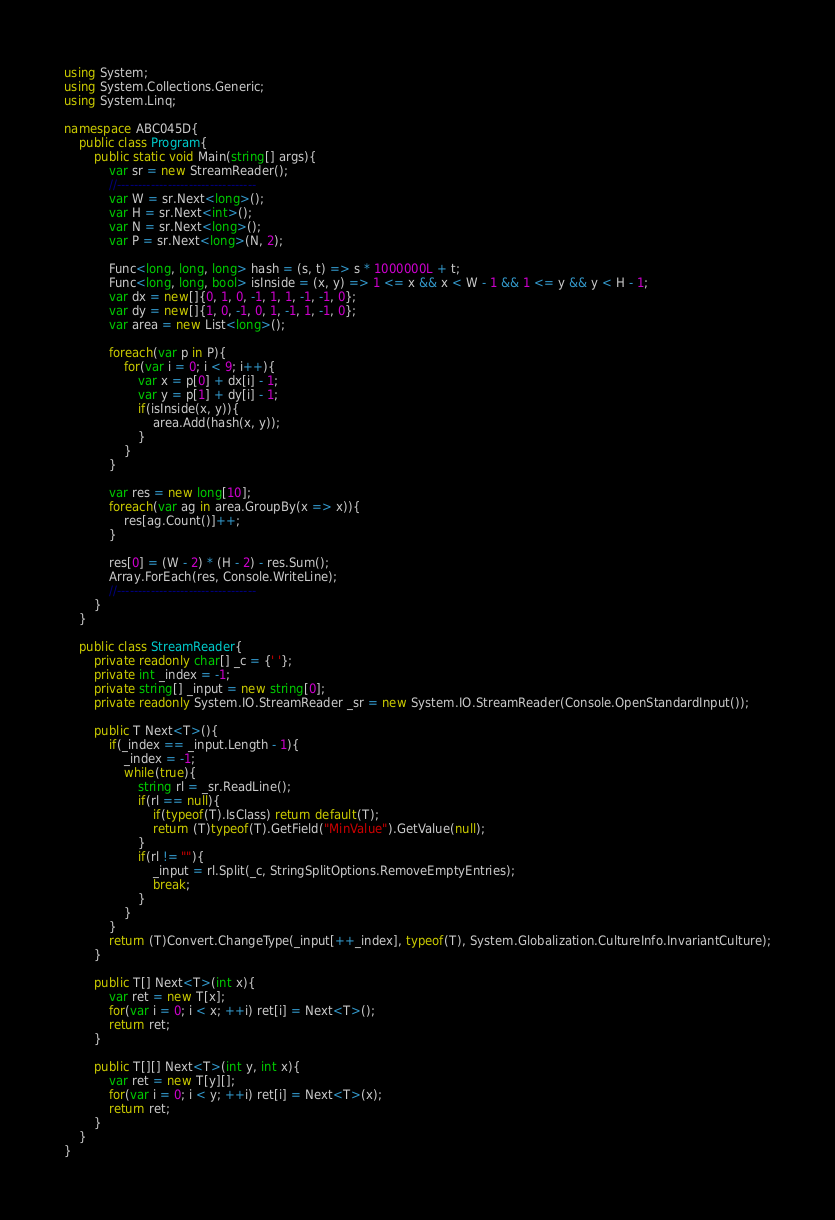Convert code to text. <code><loc_0><loc_0><loc_500><loc_500><_C#_>using System;
using System.Collections.Generic;
using System.Linq;

namespace ABC045D{
    public class Program{
        public static void Main(string[] args){
            var sr = new StreamReader();
            //---------------------------------
            var W = sr.Next<long>();
            var H = sr.Next<int>();
            var N = sr.Next<long>();
            var P = sr.Next<long>(N, 2);

            Func<long, long, long> hash = (s, t) => s * 1000000L + t;
            Func<long, long, bool> isInside = (x, y) => 1 <= x && x < W - 1 && 1 <= y && y < H - 1;
            var dx = new[]{0, 1, 0, -1, 1, 1, -1, -1, 0};
            var dy = new[]{1, 0, -1, 0, 1, -1, 1, -1, 0};
            var area = new List<long>();

            foreach(var p in P){
                for(var i = 0; i < 9; i++){
                    var x = p[0] + dx[i] - 1;
                    var y = p[1] + dy[i] - 1;
                    if(isInside(x, y)){
                        area.Add(hash(x, y));
                    }
                }
            }

            var res = new long[10];
            foreach(var ag in area.GroupBy(x => x)){
                res[ag.Count()]++;
            }

            res[0] = (W - 2) * (H - 2) - res.Sum();
            Array.ForEach(res, Console.WriteLine);
            //---------------------------------
        }
    }

    public class StreamReader{
        private readonly char[] _c = {' '};
        private int _index = -1;
        private string[] _input = new string[0];
        private readonly System.IO.StreamReader _sr = new System.IO.StreamReader(Console.OpenStandardInput());

        public T Next<T>(){
            if(_index == _input.Length - 1){
                _index = -1;
                while(true){
                    string rl = _sr.ReadLine();
                    if(rl == null){
                        if(typeof(T).IsClass) return default(T);
                        return (T)typeof(T).GetField("MinValue").GetValue(null);
                    }
                    if(rl != ""){
                        _input = rl.Split(_c, StringSplitOptions.RemoveEmptyEntries);
                        break;
                    }
                }
            }
            return (T)Convert.ChangeType(_input[++_index], typeof(T), System.Globalization.CultureInfo.InvariantCulture);
        }

        public T[] Next<T>(int x){
            var ret = new T[x];
            for(var i = 0; i < x; ++i) ret[i] = Next<T>();
            return ret;
        }

        public T[][] Next<T>(int y, int x){
            var ret = new T[y][];
            for(var i = 0; i < y; ++i) ret[i] = Next<T>(x);
            return ret;
        }
    }
}</code> 